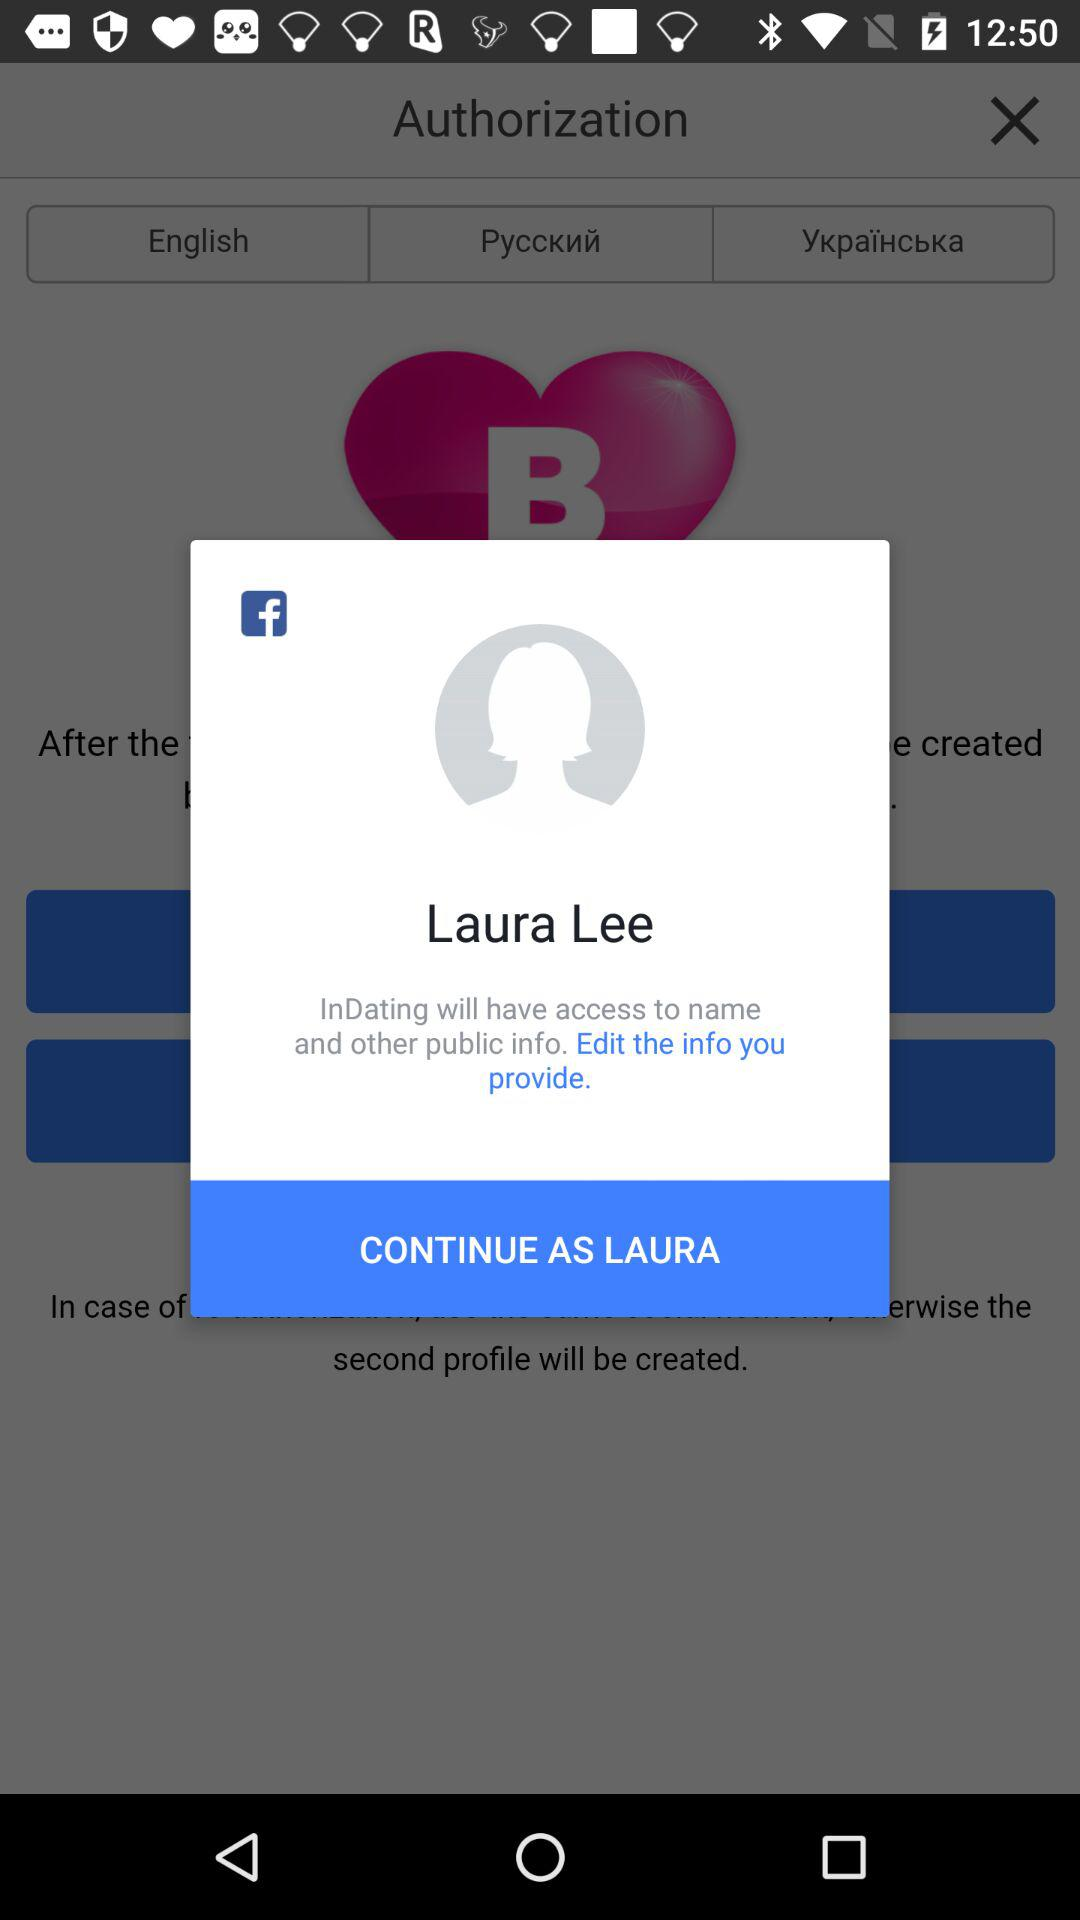Which application is asking for permission? The application is "InDating". 